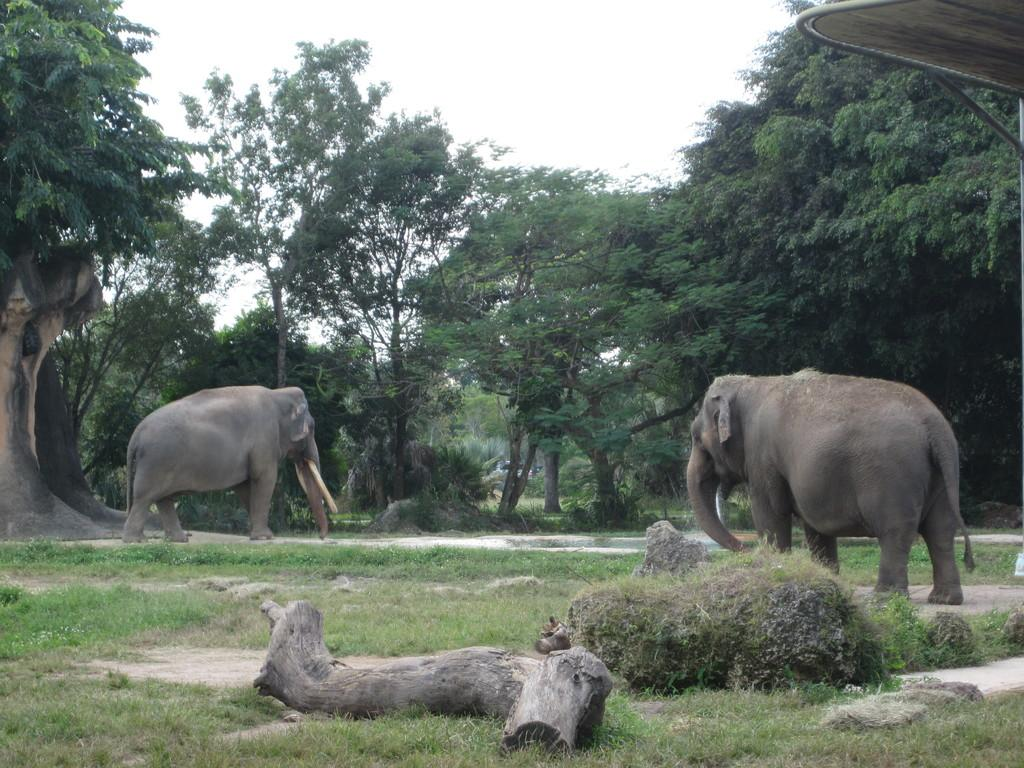How many elephants are in the image? There are two elephants in the image. What is the position of the elephants in the image? The elephants are standing on the ground. What object can be seen in the foreground of the image? There is a wood log in the foreground of the image. What type of structure is visible in the background of the image? There is a shed in the background of the image. What part of the natural environment is visible in the image? The sky is visible in the background of the image. What type of oranges are being carried by the porter in the image? There is no porter or oranges present in the image; it features two elephants standing on the ground. How does the anger of the elephants manifest in the image? There is no indication of anger in the image; the elephants are simply standing on the ground. 